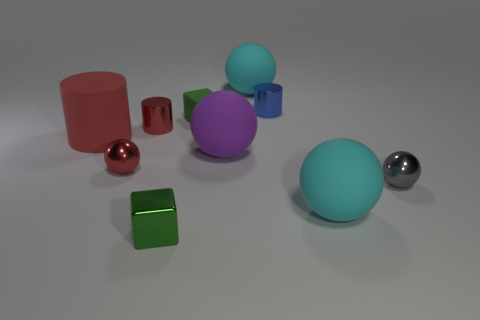Subtract all gray balls. How many balls are left? 4 Subtract all red spheres. How many spheres are left? 4 Subtract 2 spheres. How many spheres are left? 3 Subtract all gray spheres. Subtract all red cylinders. How many spheres are left? 4 Subtract all cylinders. How many objects are left? 7 Subtract 0 green cylinders. How many objects are left? 10 Subtract all small brown matte cubes. Subtract all red metal objects. How many objects are left? 8 Add 3 big cyan rubber balls. How many big cyan rubber balls are left? 5 Add 2 blue objects. How many blue objects exist? 3 